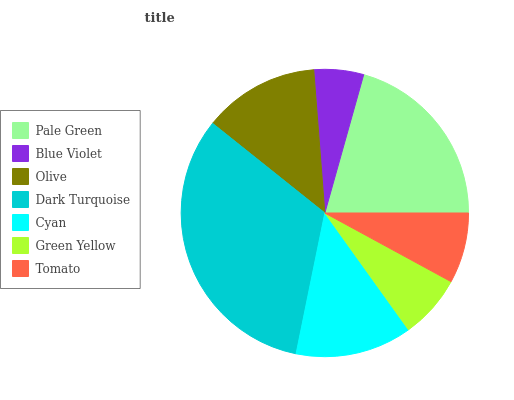Is Blue Violet the minimum?
Answer yes or no. Yes. Is Dark Turquoise the maximum?
Answer yes or no. Yes. Is Olive the minimum?
Answer yes or no. No. Is Olive the maximum?
Answer yes or no. No. Is Olive greater than Blue Violet?
Answer yes or no. Yes. Is Blue Violet less than Olive?
Answer yes or no. Yes. Is Blue Violet greater than Olive?
Answer yes or no. No. Is Olive less than Blue Violet?
Answer yes or no. No. Is Olive the high median?
Answer yes or no. Yes. Is Olive the low median?
Answer yes or no. Yes. Is Pale Green the high median?
Answer yes or no. No. Is Pale Green the low median?
Answer yes or no. No. 